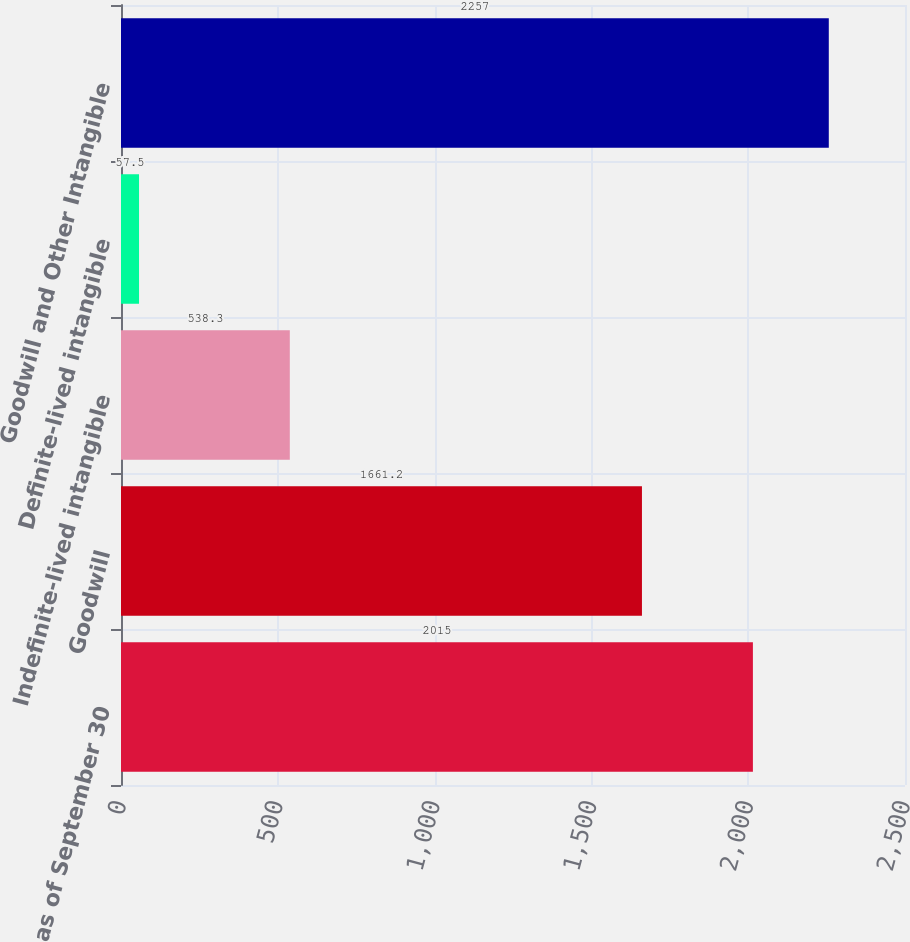Convert chart to OTSL. <chart><loc_0><loc_0><loc_500><loc_500><bar_chart><fcel>as of September 30<fcel>Goodwill<fcel>Indefinite-lived intangible<fcel>Definite-lived intangible<fcel>Goodwill and Other Intangible<nl><fcel>2015<fcel>1661.2<fcel>538.3<fcel>57.5<fcel>2257<nl></chart> 